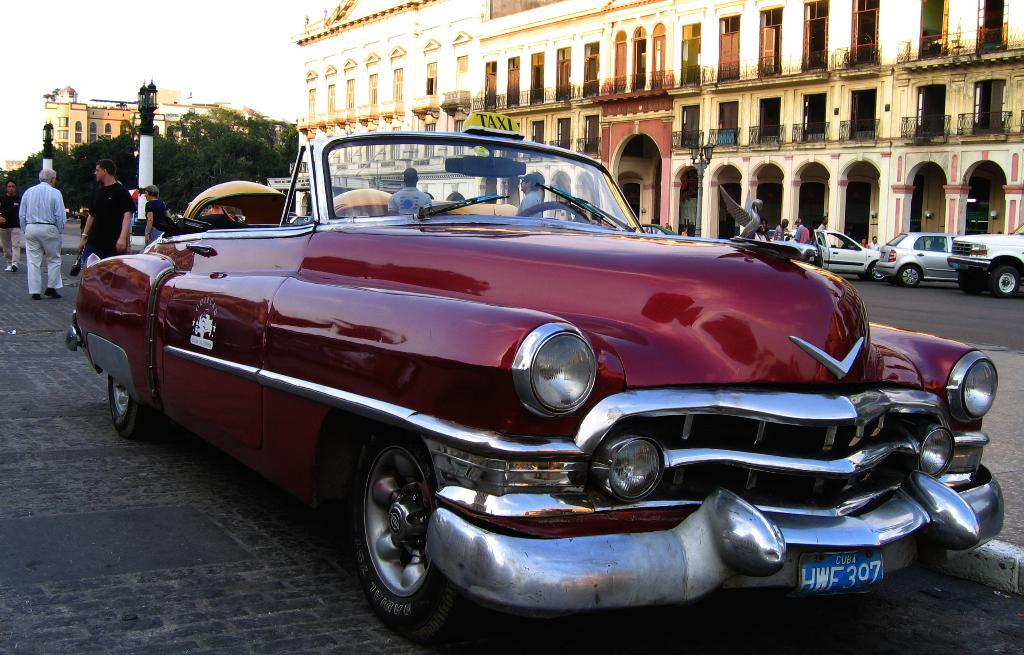What can be seen in the image? There are vehicles and a group of people in the image. What is visible in the background of the image? There are buildings, trees, poles, and lights visible in the background of the image. How many types of structures can be seen in the background? There are at least three types of structures visible in the background: buildings, poles, and lights. What type of bell can be heard ringing in the image? There is no bell present in the image, and therefore no sound can be heard. 